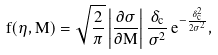<formula> <loc_0><loc_0><loc_500><loc_500>f ( \eta , M ) = \sqrt { \frac { 2 } { \pi } } \left | \frac { \partial \sigma } { \partial M } \right | \frac { \delta _ { c } } { \sigma ^ { 2 } } \, e ^ { - \frac { \delta _ { c } ^ { 2 } } { 2 \sigma ^ { 2 } } } ,</formula> 